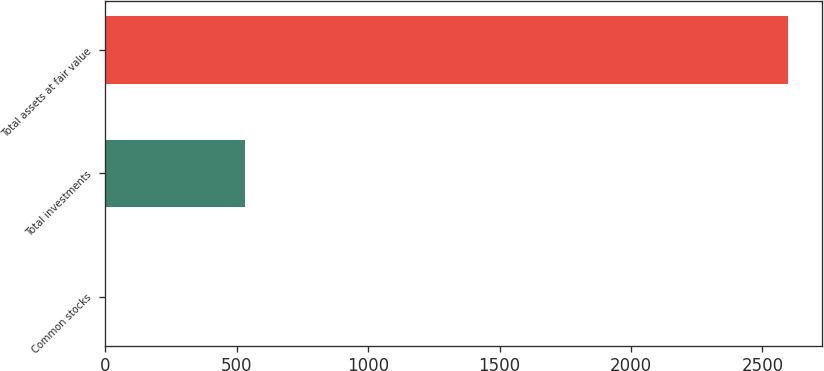Convert chart. <chart><loc_0><loc_0><loc_500><loc_500><bar_chart><fcel>Common stocks<fcel>Total investments<fcel>Total assets at fair value<nl><fcel>3<fcel>532<fcel>2597<nl></chart> 